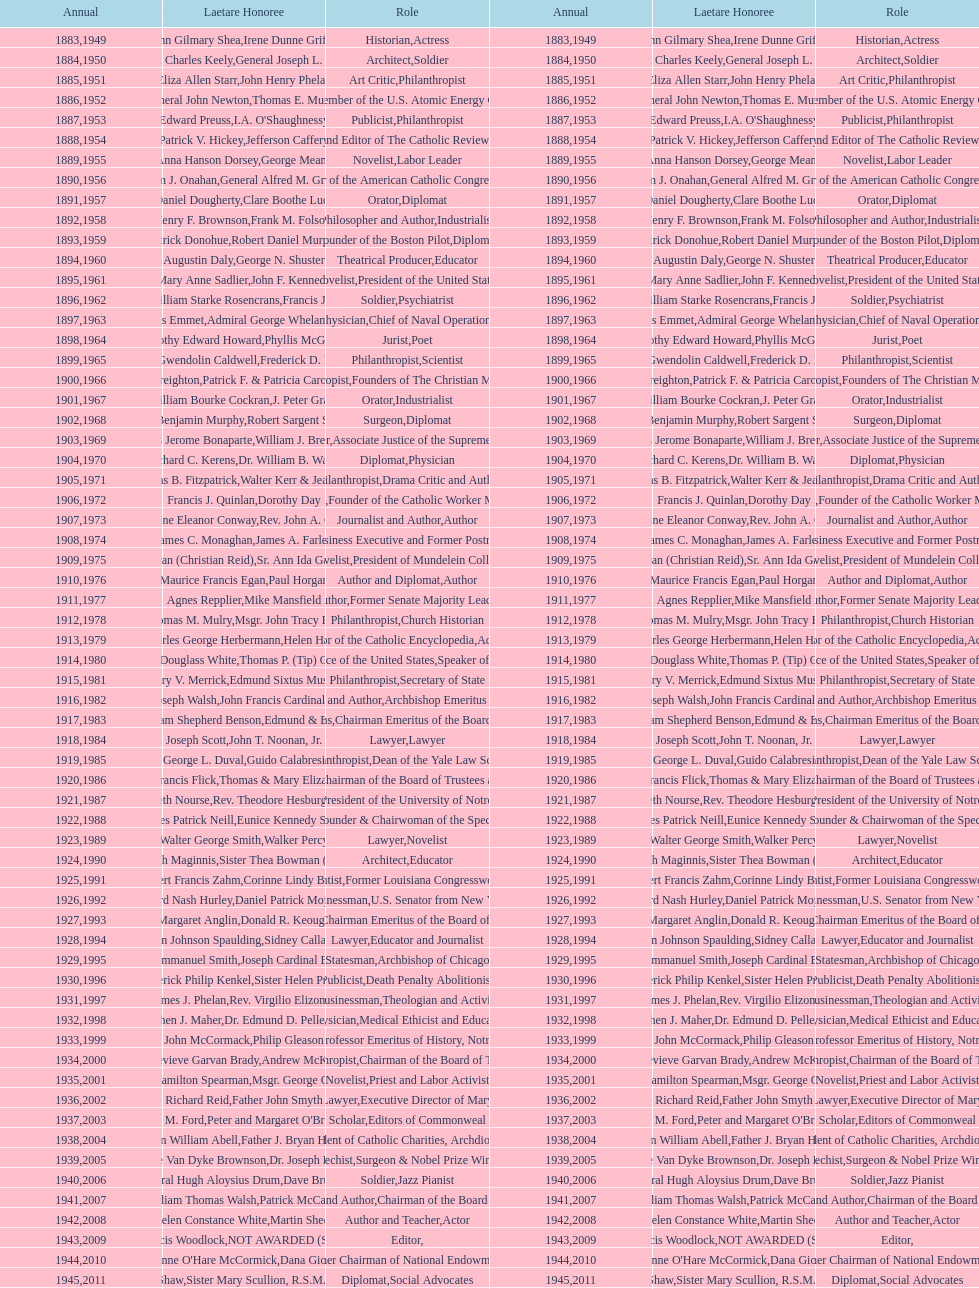Who has won this medal and the nobel prize as well? Dr. Joseph E. Murray. 